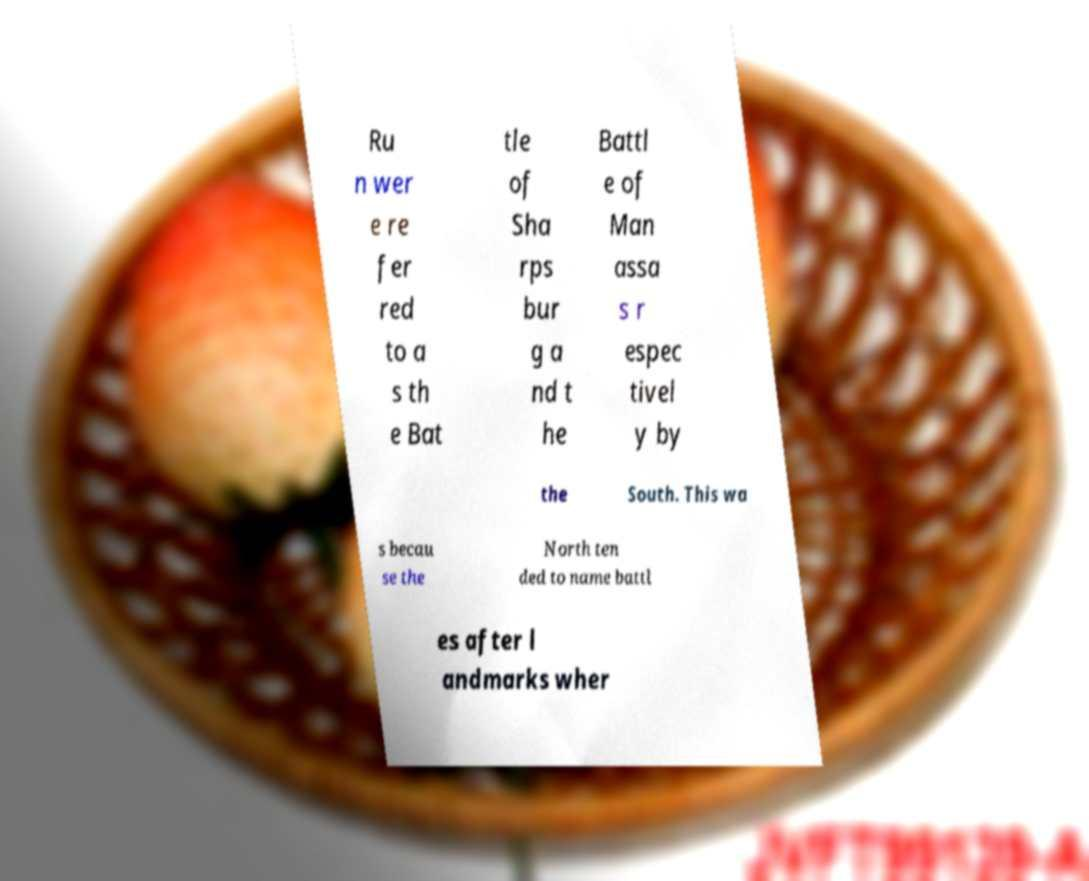For documentation purposes, I need the text within this image transcribed. Could you provide that? Ru n wer e re fer red to a s th e Bat tle of Sha rps bur g a nd t he Battl e of Man assa s r espec tivel y by the South. This wa s becau se the North ten ded to name battl es after l andmarks wher 